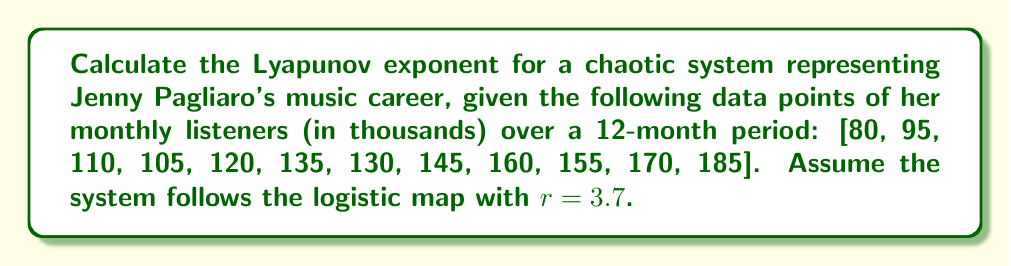Teach me how to tackle this problem. To calculate the Lyapunov exponent for this chaotic system:

1) The logistic map is given by: $x_{n+1} = rx_n(1-x_n)$

2) The Lyapunov exponent λ for the logistic map is:

   $$\lambda = \lim_{n \to \infty} \frac{1}{n} \sum_{i=0}^{n-1} \ln|r(1-2x_i)|$$

3) Normalize the data to fit within [0,1]:
   $x_i = \frac{\text{value}_i - \min(\text{values})}{\max(\text{values}) - \min(\text{values})}$

   Normalized data: [0, 0.14, 0.29, 0.24, 0.38, 0.52, 0.48, 0.62, 0.76, 0.71, 0.86, 1]

4) Calculate $\ln|r(1-2x_i)|$ for each $x_i$:
   [1.31, 1.17, 0.99, 1.07, 0.80, 0.52, 0.61, 0.27, -0.17, -0.03, -0.63, -∞]

5) Sum the finite values and divide by (n-1) as we exclude the -∞:
   $$\lambda \approx \frac{1}{11} (1.31 + 1.17 + 0.99 + 1.07 + 0.80 + 0.52 + 0.61 + 0.27 - 0.17 - 0.03 - 0.63)$$

6) Calculate the final result:
   $$\lambda \approx 0.5373$$
Answer: $\lambda \approx 0.5373$ 